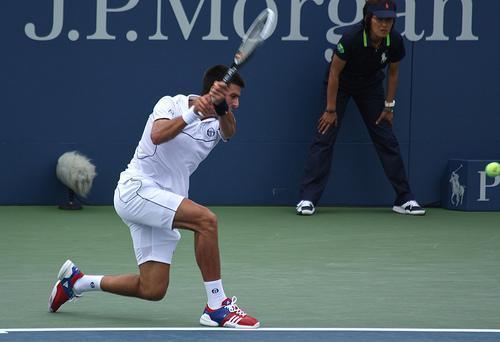How many people are in the picture?
Give a very brief answer. 2. 